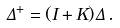<formula> <loc_0><loc_0><loc_500><loc_500>\Delta ^ { + } = ( I + K ) \Delta \, .</formula> 